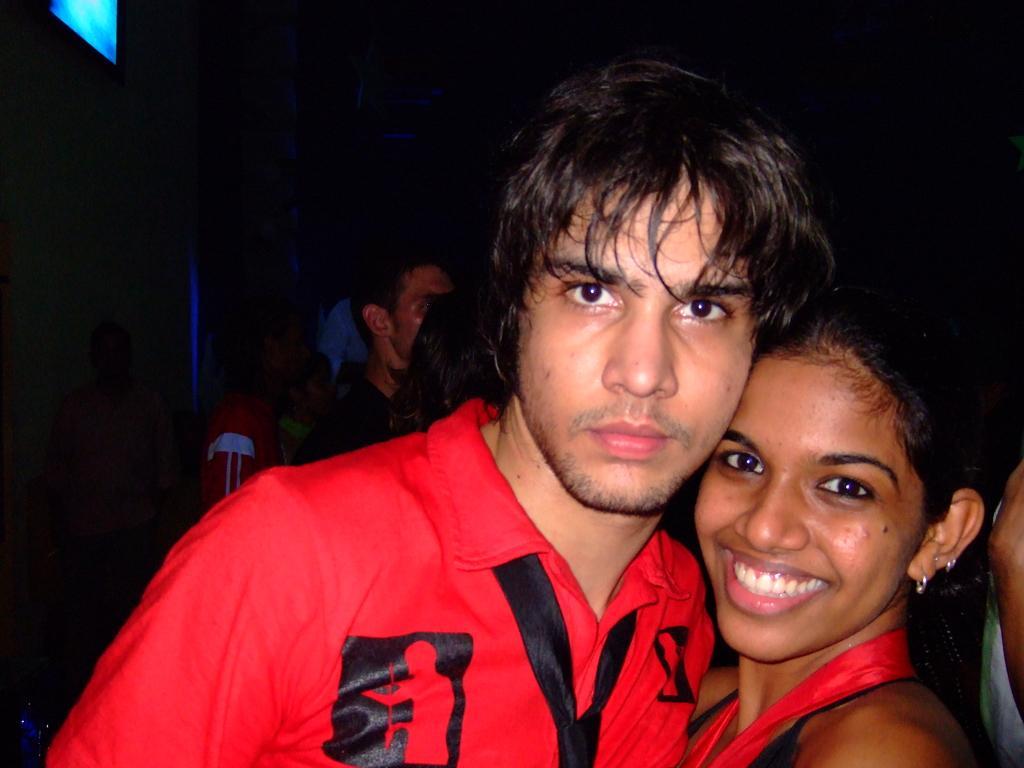Can you describe this image briefly? In the foreground of the picture I can see two persons. There is a woman on the right side and she is smiling. I can see a man on the left side wearing a red color T-shirt. In the background, I can see a few persons. It is looking like a television on the wall on the top left side of the picture. 